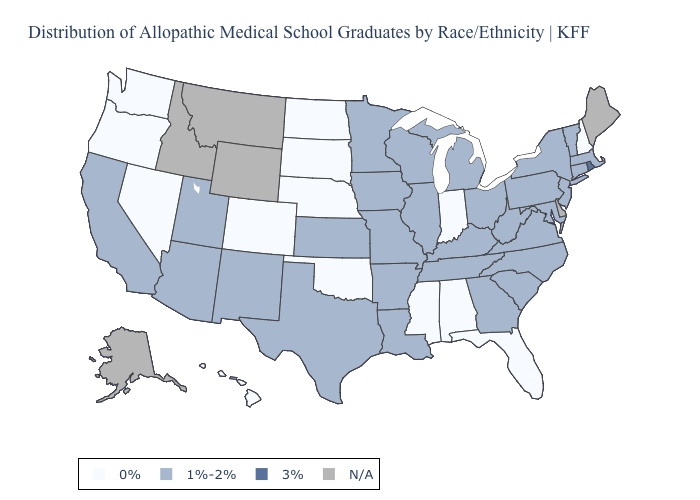Name the states that have a value in the range 3%?
Keep it brief. Rhode Island. Is the legend a continuous bar?
Short answer required. No. Name the states that have a value in the range 1%-2%?
Concise answer only. Arizona, Arkansas, California, Connecticut, Georgia, Illinois, Iowa, Kansas, Kentucky, Louisiana, Maryland, Massachusetts, Michigan, Minnesota, Missouri, New Jersey, New Mexico, New York, North Carolina, Ohio, Pennsylvania, South Carolina, Tennessee, Texas, Utah, Vermont, Virginia, West Virginia, Wisconsin. Does Alabama have the lowest value in the South?
Write a very short answer. Yes. What is the lowest value in states that border New Jersey?
Short answer required. 1%-2%. What is the value of Kentucky?
Concise answer only. 1%-2%. What is the value of Missouri?
Be succinct. 1%-2%. Which states have the highest value in the USA?
Quick response, please. Rhode Island. What is the value of Nevada?
Quick response, please. 0%. What is the value of South Dakota?
Keep it brief. 0%. Does Rhode Island have the highest value in the USA?
Answer briefly. Yes. Which states have the lowest value in the Northeast?
Give a very brief answer. New Hampshire. What is the lowest value in the MidWest?
Keep it brief. 0%. How many symbols are there in the legend?
Write a very short answer. 4. What is the lowest value in the USA?
Concise answer only. 0%. 